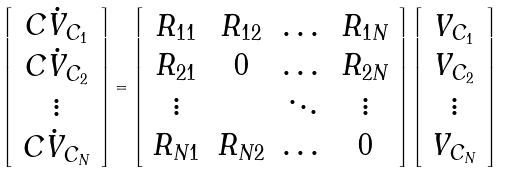Convert formula to latex. <formula><loc_0><loc_0><loc_500><loc_500>\left [ \begin{array} { c } C \dot { V } _ { C _ { 1 } } \\ C \dot { V } _ { C _ { 2 } } \\ \vdots \\ C \dot { V } _ { C _ { N } } \end{array} \right ] = \left [ \begin{array} { c c c c } R _ { 1 1 } & R _ { 1 2 } & \dots & R _ { 1 N } \\ R _ { 2 1 } & 0 & \dots & R _ { 2 N } \\ \vdots & & \ddots & \vdots \\ R _ { N 1 } & R _ { N 2 } & \dots & 0 \end{array} \right ] \left [ \begin{array} { c } V _ { C _ { 1 } } \\ V _ { C _ { 2 } } \\ \vdots \\ V _ { C _ { N } } \end{array} \right ]</formula> 